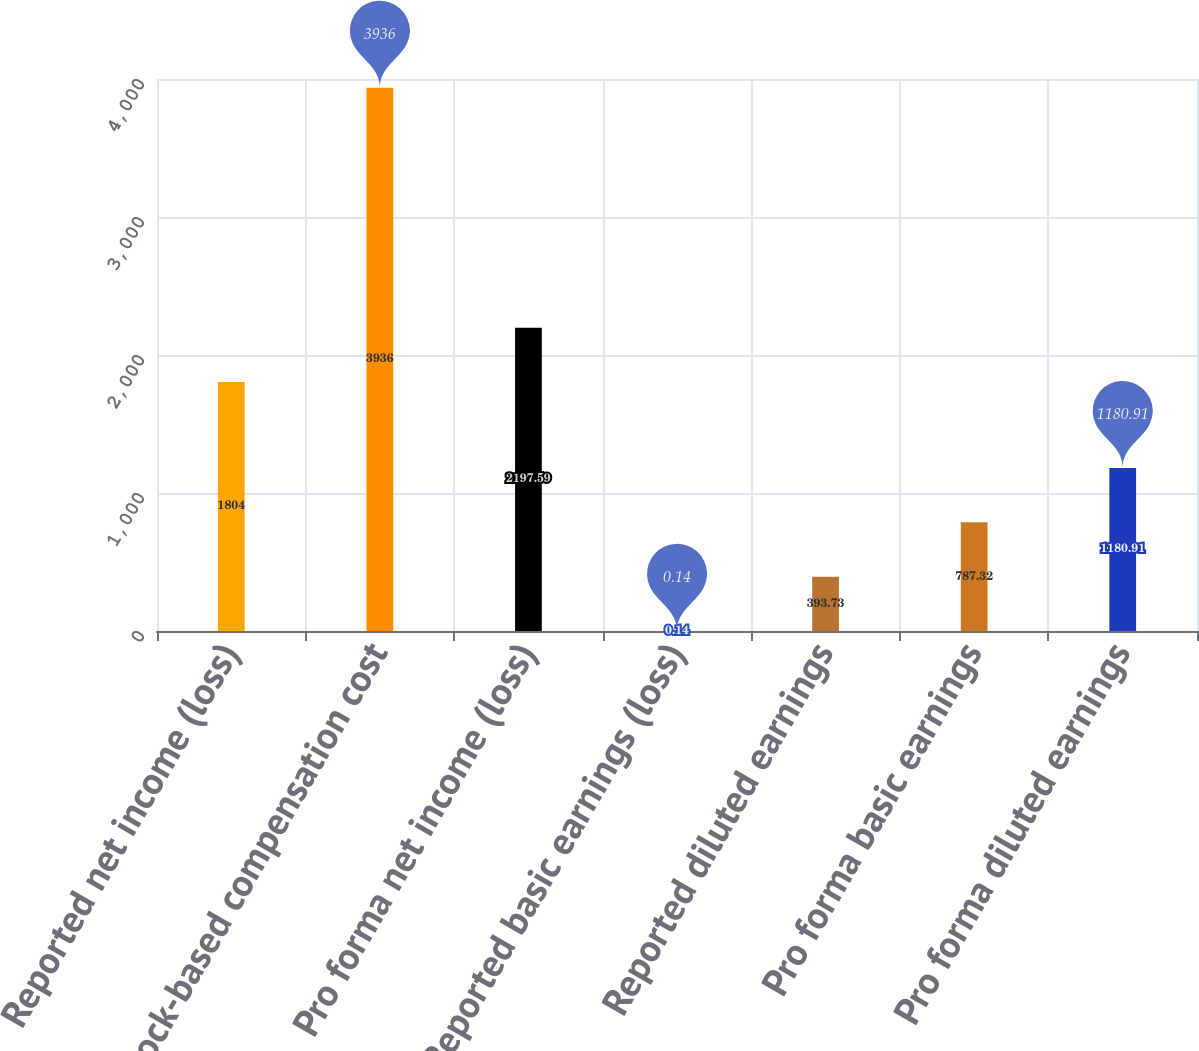Convert chart to OTSL. <chart><loc_0><loc_0><loc_500><loc_500><bar_chart><fcel>Reported net income (loss)<fcel>Stock-based compensation cost<fcel>Pro forma net income (loss)<fcel>Reported basic earnings (loss)<fcel>Reported diluted earnings<fcel>Pro forma basic earnings<fcel>Pro forma diluted earnings<nl><fcel>1804<fcel>3936<fcel>2197.59<fcel>0.14<fcel>393.73<fcel>787.32<fcel>1180.91<nl></chart> 